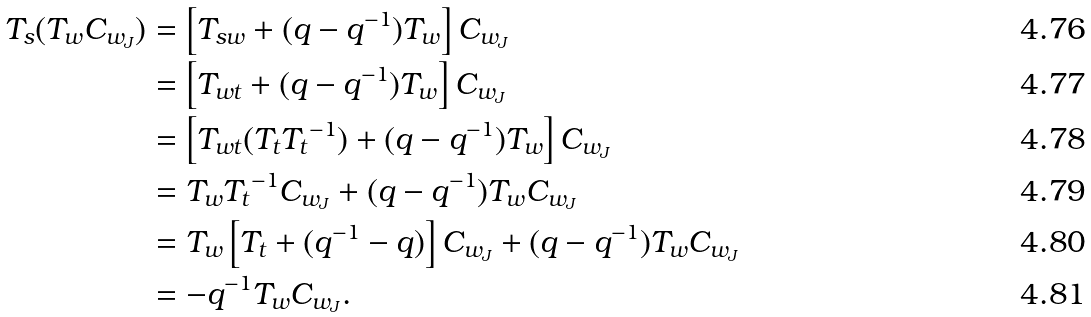Convert formula to latex. <formula><loc_0><loc_0><loc_500><loc_500>T _ { s } ( T _ { w } C _ { w _ { J } } ) & = \left [ T _ { s w } + ( q - q ^ { - 1 } ) T _ { w } \right ] C _ { w _ { J } } \\ & = \left [ T _ { w t } + ( q - q ^ { - 1 } ) T _ { w } \right ] C _ { w _ { J } } \\ & = \left [ T _ { w t } ( T _ { t } { T _ { t } } ^ { - 1 } ) + ( q - q ^ { - 1 } ) T _ { w } \right ] C _ { w _ { J } } \\ & = T _ { w } { T _ { t } } ^ { - 1 } C _ { w _ { J } } + ( q - q ^ { - 1 } ) T _ { w } C _ { w _ { J } } \\ & = T _ { w } \left [ T _ { t } + ( q ^ { - 1 } - q ) \right ] C _ { w _ { J } } + ( q - q ^ { - 1 } ) T _ { w } C _ { w _ { J } } \\ & = - q ^ { - 1 } T _ { w } C _ { w _ { J } } .</formula> 